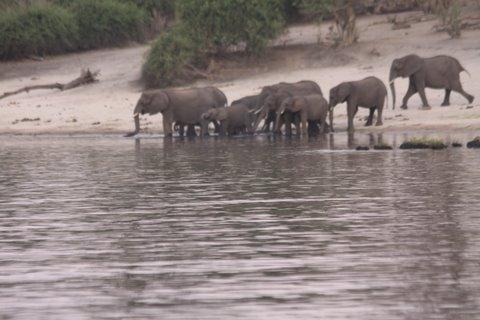How many elephants can you see?
Give a very brief answer. 2. How many people are on the boat that is the main focus?
Give a very brief answer. 0. 